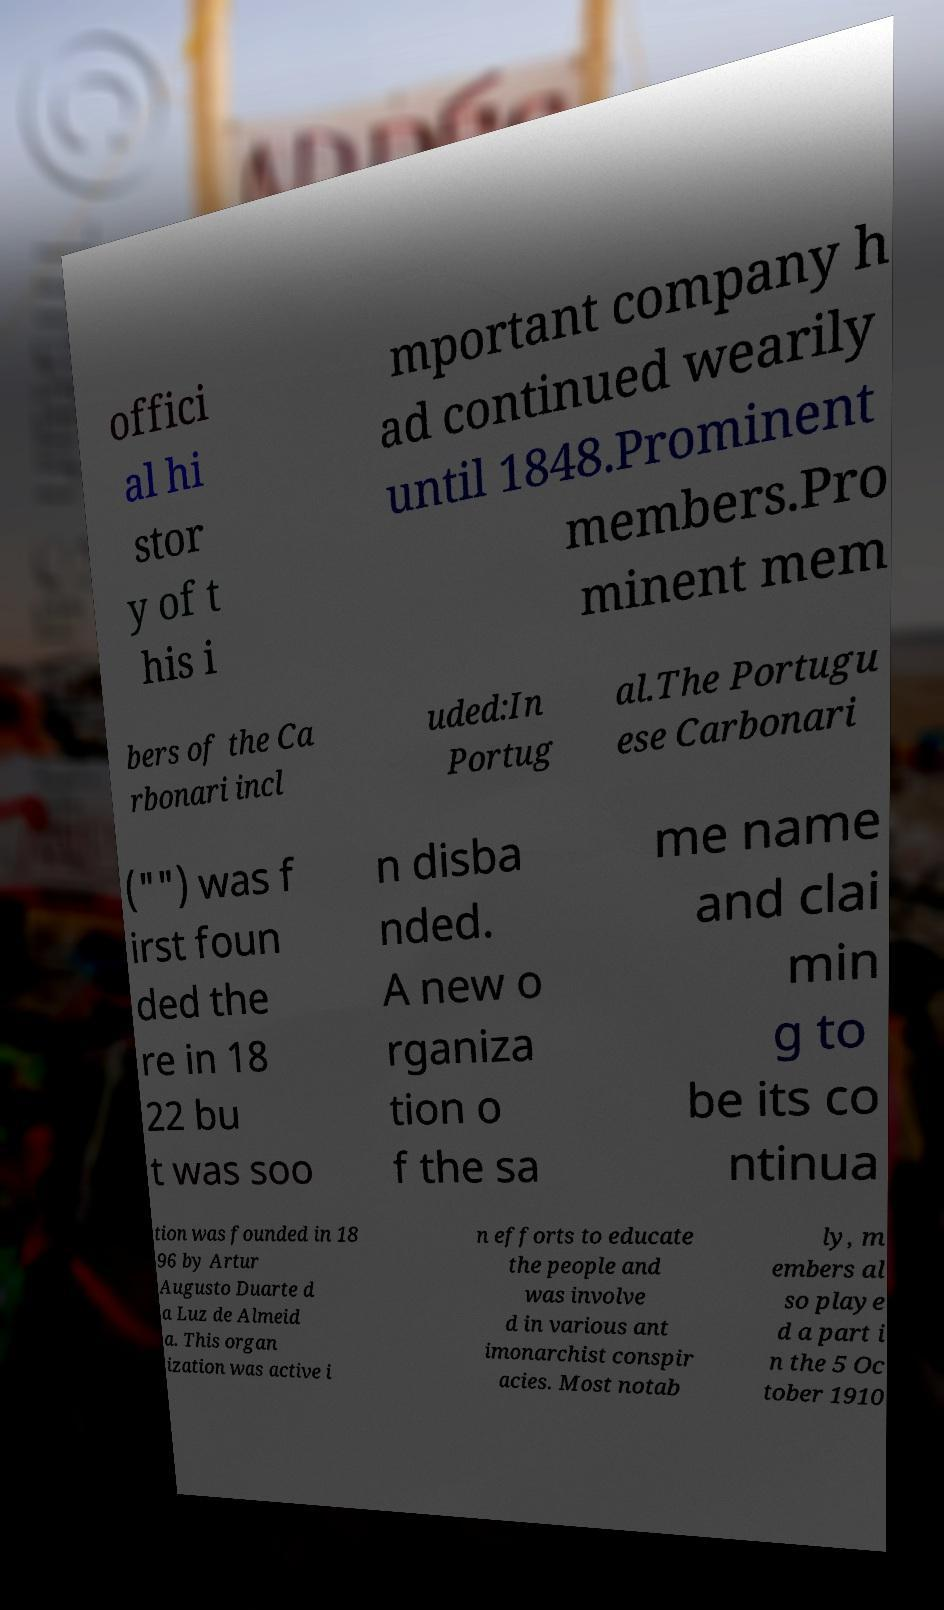Can you accurately transcribe the text from the provided image for me? offici al hi stor y of t his i mportant company h ad continued wearily until 1848.Prominent members.Pro minent mem bers of the Ca rbonari incl uded:In Portug al.The Portugu ese Carbonari ("") was f irst foun ded the re in 18 22 bu t was soo n disba nded. A new o rganiza tion o f the sa me name and clai min g to be its co ntinua tion was founded in 18 96 by Artur Augusto Duarte d a Luz de Almeid a. This organ ization was active i n efforts to educate the people and was involve d in various ant imonarchist conspir acies. Most notab ly, m embers al so playe d a part i n the 5 Oc tober 1910 